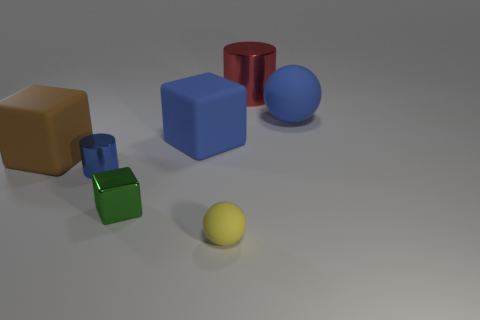How many other objects are there of the same color as the large metallic cylinder?
Offer a terse response. 0. What is the shape of the large thing that is on the left side of the small blue cylinder?
Offer a terse response. Cube. How many things are big blue rubber balls or large objects?
Ensure brevity in your answer.  4. Do the red cylinder and the blue rubber thing that is to the right of the large metal cylinder have the same size?
Provide a succinct answer. Yes. How many other objects are the same material as the big cylinder?
Your answer should be compact. 2. How many objects are small blue objects that are left of the small matte ball or small blue cylinders that are in front of the large metallic cylinder?
Provide a short and direct response. 1. What material is the other small thing that is the same shape as the brown rubber thing?
Ensure brevity in your answer.  Metal. Is there a blue shiny object?
Provide a succinct answer. Yes. There is a shiny thing that is to the right of the small blue thing and in front of the large metallic cylinder; what size is it?
Your response must be concise. Small. What shape is the big red shiny thing?
Your answer should be very brief. Cylinder. 